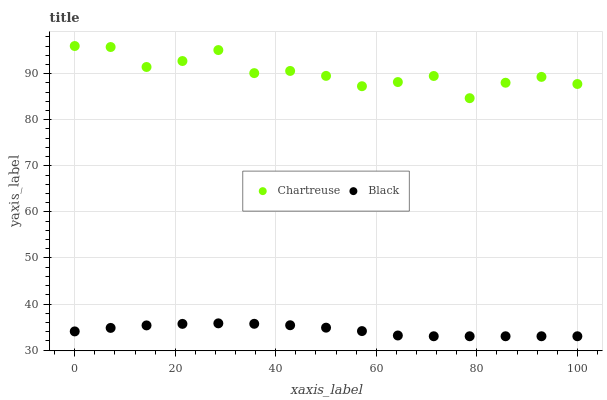Does Black have the minimum area under the curve?
Answer yes or no. Yes. Does Chartreuse have the maximum area under the curve?
Answer yes or no. Yes. Does Black have the maximum area under the curve?
Answer yes or no. No. Is Black the smoothest?
Answer yes or no. Yes. Is Chartreuse the roughest?
Answer yes or no. Yes. Is Black the roughest?
Answer yes or no. No. Does Black have the lowest value?
Answer yes or no. Yes. Does Chartreuse have the highest value?
Answer yes or no. Yes. Does Black have the highest value?
Answer yes or no. No. Is Black less than Chartreuse?
Answer yes or no. Yes. Is Chartreuse greater than Black?
Answer yes or no. Yes. Does Black intersect Chartreuse?
Answer yes or no. No. 